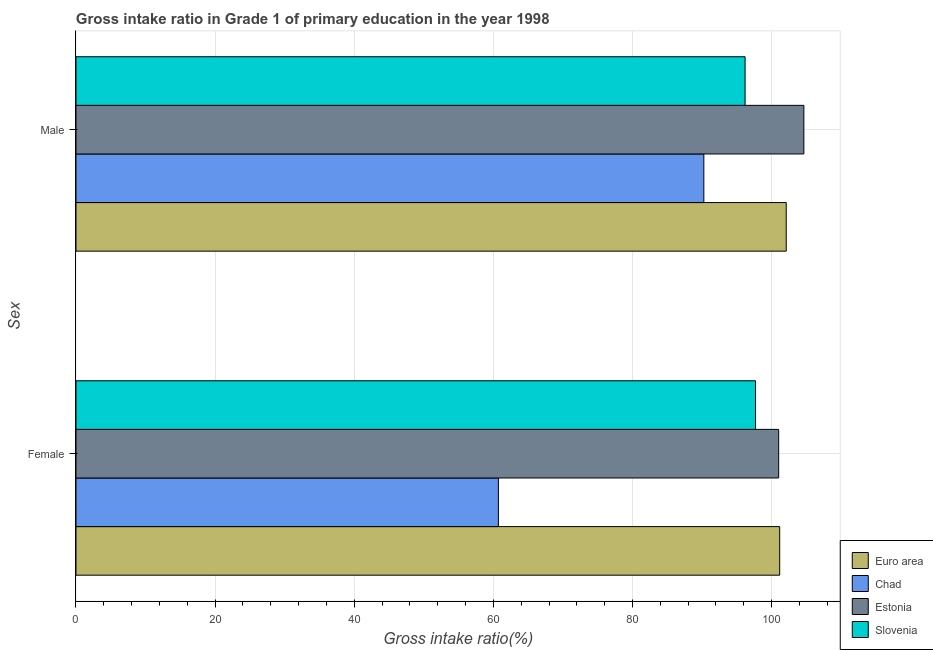How many different coloured bars are there?
Your answer should be compact. 4. How many groups of bars are there?
Your answer should be compact. 2. Are the number of bars per tick equal to the number of legend labels?
Offer a terse response. Yes. Are the number of bars on each tick of the Y-axis equal?
Give a very brief answer. Yes. How many bars are there on the 1st tick from the top?
Your answer should be very brief. 4. What is the gross intake ratio(female) in Estonia?
Offer a terse response. 101.02. Across all countries, what is the maximum gross intake ratio(male)?
Keep it short and to the point. 104.64. Across all countries, what is the minimum gross intake ratio(male)?
Your answer should be compact. 90.26. In which country was the gross intake ratio(female) maximum?
Ensure brevity in your answer.  Euro area. In which country was the gross intake ratio(female) minimum?
Offer a terse response. Chad. What is the total gross intake ratio(female) in the graph?
Keep it short and to the point. 360.59. What is the difference between the gross intake ratio(male) in Estonia and that in Slovenia?
Keep it short and to the point. 8.45. What is the difference between the gross intake ratio(male) in Estonia and the gross intake ratio(female) in Chad?
Your response must be concise. 43.91. What is the average gross intake ratio(male) per country?
Your answer should be very brief. 98.3. What is the difference between the gross intake ratio(male) and gross intake ratio(female) in Chad?
Keep it short and to the point. 29.54. What is the ratio of the gross intake ratio(female) in Slovenia to that in Estonia?
Offer a very short reply. 0.97. Is the gross intake ratio(male) in Euro area less than that in Estonia?
Provide a short and direct response. Yes. What does the 3rd bar from the top in Male represents?
Your response must be concise. Chad. What does the 4th bar from the bottom in Female represents?
Your answer should be very brief. Slovenia. How many bars are there?
Your answer should be very brief. 8. Are all the bars in the graph horizontal?
Your answer should be very brief. Yes. How many countries are there in the graph?
Make the answer very short. 4. Are the values on the major ticks of X-axis written in scientific E-notation?
Give a very brief answer. No. Does the graph contain any zero values?
Offer a very short reply. No. How many legend labels are there?
Your answer should be compact. 4. How are the legend labels stacked?
Keep it short and to the point. Vertical. What is the title of the graph?
Your answer should be compact. Gross intake ratio in Grade 1 of primary education in the year 1998. What is the label or title of the X-axis?
Keep it short and to the point. Gross intake ratio(%). What is the label or title of the Y-axis?
Your answer should be very brief. Sex. What is the Gross intake ratio(%) in Euro area in Female?
Keep it short and to the point. 101.16. What is the Gross intake ratio(%) of Chad in Female?
Make the answer very short. 60.72. What is the Gross intake ratio(%) of Estonia in Female?
Provide a succinct answer. 101.02. What is the Gross intake ratio(%) in Slovenia in Female?
Make the answer very short. 97.69. What is the Gross intake ratio(%) in Euro area in Male?
Give a very brief answer. 102.1. What is the Gross intake ratio(%) of Chad in Male?
Your response must be concise. 90.26. What is the Gross intake ratio(%) of Estonia in Male?
Provide a succinct answer. 104.64. What is the Gross intake ratio(%) in Slovenia in Male?
Your answer should be very brief. 96.19. Across all Sex, what is the maximum Gross intake ratio(%) in Euro area?
Give a very brief answer. 102.1. Across all Sex, what is the maximum Gross intake ratio(%) in Chad?
Make the answer very short. 90.26. Across all Sex, what is the maximum Gross intake ratio(%) of Estonia?
Provide a short and direct response. 104.64. Across all Sex, what is the maximum Gross intake ratio(%) of Slovenia?
Keep it short and to the point. 97.69. Across all Sex, what is the minimum Gross intake ratio(%) of Euro area?
Ensure brevity in your answer.  101.16. Across all Sex, what is the minimum Gross intake ratio(%) in Chad?
Your answer should be very brief. 60.72. Across all Sex, what is the minimum Gross intake ratio(%) of Estonia?
Give a very brief answer. 101.02. Across all Sex, what is the minimum Gross intake ratio(%) in Slovenia?
Provide a short and direct response. 96.19. What is the total Gross intake ratio(%) of Euro area in the graph?
Make the answer very short. 203.26. What is the total Gross intake ratio(%) in Chad in the graph?
Offer a very short reply. 150.98. What is the total Gross intake ratio(%) of Estonia in the graph?
Offer a terse response. 205.65. What is the total Gross intake ratio(%) of Slovenia in the graph?
Your answer should be very brief. 193.88. What is the difference between the Gross intake ratio(%) in Euro area in Female and that in Male?
Offer a very short reply. -0.94. What is the difference between the Gross intake ratio(%) of Chad in Female and that in Male?
Your answer should be compact. -29.54. What is the difference between the Gross intake ratio(%) of Estonia in Female and that in Male?
Offer a terse response. -3.62. What is the difference between the Gross intake ratio(%) of Slovenia in Female and that in Male?
Your answer should be compact. 1.5. What is the difference between the Gross intake ratio(%) in Euro area in Female and the Gross intake ratio(%) in Chad in Male?
Provide a succinct answer. 10.9. What is the difference between the Gross intake ratio(%) of Euro area in Female and the Gross intake ratio(%) of Estonia in Male?
Your answer should be compact. -3.48. What is the difference between the Gross intake ratio(%) of Euro area in Female and the Gross intake ratio(%) of Slovenia in Male?
Keep it short and to the point. 4.97. What is the difference between the Gross intake ratio(%) of Chad in Female and the Gross intake ratio(%) of Estonia in Male?
Your answer should be compact. -43.91. What is the difference between the Gross intake ratio(%) in Chad in Female and the Gross intake ratio(%) in Slovenia in Male?
Give a very brief answer. -35.46. What is the difference between the Gross intake ratio(%) in Estonia in Female and the Gross intake ratio(%) in Slovenia in Male?
Offer a terse response. 4.83. What is the average Gross intake ratio(%) in Euro area per Sex?
Provide a succinct answer. 101.63. What is the average Gross intake ratio(%) in Chad per Sex?
Offer a very short reply. 75.49. What is the average Gross intake ratio(%) of Estonia per Sex?
Provide a short and direct response. 102.83. What is the average Gross intake ratio(%) in Slovenia per Sex?
Provide a short and direct response. 96.94. What is the difference between the Gross intake ratio(%) in Euro area and Gross intake ratio(%) in Chad in Female?
Make the answer very short. 40.44. What is the difference between the Gross intake ratio(%) in Euro area and Gross intake ratio(%) in Estonia in Female?
Provide a succinct answer. 0.14. What is the difference between the Gross intake ratio(%) in Euro area and Gross intake ratio(%) in Slovenia in Female?
Give a very brief answer. 3.47. What is the difference between the Gross intake ratio(%) of Chad and Gross intake ratio(%) of Estonia in Female?
Ensure brevity in your answer.  -40.29. What is the difference between the Gross intake ratio(%) in Chad and Gross intake ratio(%) in Slovenia in Female?
Your response must be concise. -36.96. What is the difference between the Gross intake ratio(%) of Estonia and Gross intake ratio(%) of Slovenia in Female?
Give a very brief answer. 3.33. What is the difference between the Gross intake ratio(%) in Euro area and Gross intake ratio(%) in Chad in Male?
Make the answer very short. 11.84. What is the difference between the Gross intake ratio(%) in Euro area and Gross intake ratio(%) in Estonia in Male?
Provide a succinct answer. -2.53. What is the difference between the Gross intake ratio(%) of Euro area and Gross intake ratio(%) of Slovenia in Male?
Your answer should be very brief. 5.91. What is the difference between the Gross intake ratio(%) in Chad and Gross intake ratio(%) in Estonia in Male?
Your answer should be compact. -14.38. What is the difference between the Gross intake ratio(%) in Chad and Gross intake ratio(%) in Slovenia in Male?
Offer a terse response. -5.93. What is the difference between the Gross intake ratio(%) of Estonia and Gross intake ratio(%) of Slovenia in Male?
Give a very brief answer. 8.45. What is the ratio of the Gross intake ratio(%) of Euro area in Female to that in Male?
Ensure brevity in your answer.  0.99. What is the ratio of the Gross intake ratio(%) in Chad in Female to that in Male?
Provide a succinct answer. 0.67. What is the ratio of the Gross intake ratio(%) in Estonia in Female to that in Male?
Ensure brevity in your answer.  0.97. What is the ratio of the Gross intake ratio(%) of Slovenia in Female to that in Male?
Provide a succinct answer. 1.02. What is the difference between the highest and the second highest Gross intake ratio(%) of Euro area?
Make the answer very short. 0.94. What is the difference between the highest and the second highest Gross intake ratio(%) in Chad?
Provide a short and direct response. 29.54. What is the difference between the highest and the second highest Gross intake ratio(%) of Estonia?
Offer a terse response. 3.62. What is the difference between the highest and the second highest Gross intake ratio(%) in Slovenia?
Offer a terse response. 1.5. What is the difference between the highest and the lowest Gross intake ratio(%) in Euro area?
Ensure brevity in your answer.  0.94. What is the difference between the highest and the lowest Gross intake ratio(%) in Chad?
Offer a terse response. 29.54. What is the difference between the highest and the lowest Gross intake ratio(%) in Estonia?
Make the answer very short. 3.62. What is the difference between the highest and the lowest Gross intake ratio(%) in Slovenia?
Your response must be concise. 1.5. 